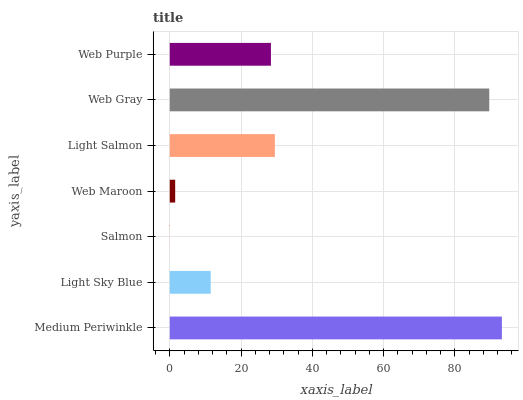Is Salmon the minimum?
Answer yes or no. Yes. Is Medium Periwinkle the maximum?
Answer yes or no. Yes. Is Light Sky Blue the minimum?
Answer yes or no. No. Is Light Sky Blue the maximum?
Answer yes or no. No. Is Medium Periwinkle greater than Light Sky Blue?
Answer yes or no. Yes. Is Light Sky Blue less than Medium Periwinkle?
Answer yes or no. Yes. Is Light Sky Blue greater than Medium Periwinkle?
Answer yes or no. No. Is Medium Periwinkle less than Light Sky Blue?
Answer yes or no. No. Is Web Purple the high median?
Answer yes or no. Yes. Is Web Purple the low median?
Answer yes or no. Yes. Is Light Salmon the high median?
Answer yes or no. No. Is Salmon the low median?
Answer yes or no. No. 